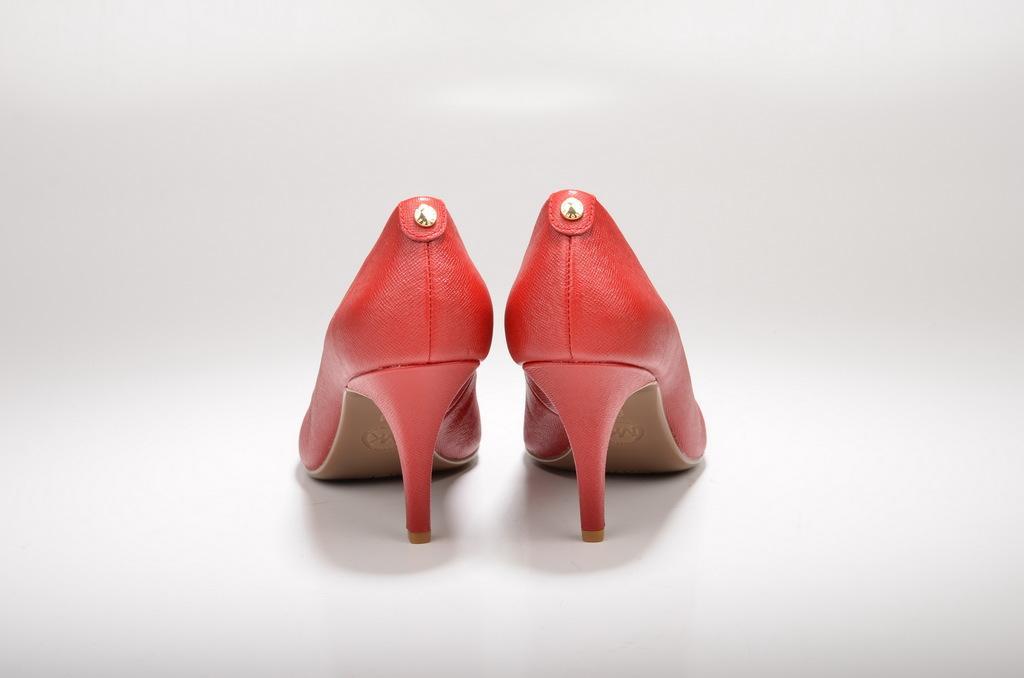How would you summarize this image in a sentence or two? In this image in the middle I can see heels, background is white. 